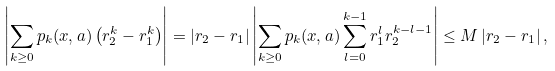Convert formula to latex. <formula><loc_0><loc_0><loc_500><loc_500>\left | \sum _ { k \geq 0 } { p _ { k } ( x , a ) \left ( r _ { 2 } ^ { k } - r _ { 1 } ^ { k } \right ) } \right | = \left | r _ { 2 } - r _ { 1 } \right | \left | \sum _ { k \geq 0 } { p _ { k } ( x , a ) \sum _ { l = 0 } ^ { k - 1 } r _ { 1 } ^ { l } r _ { 2 } ^ { k - l - 1 } } \right | \leq M \left | r _ { 2 } - r _ { 1 } \right | ,</formula> 